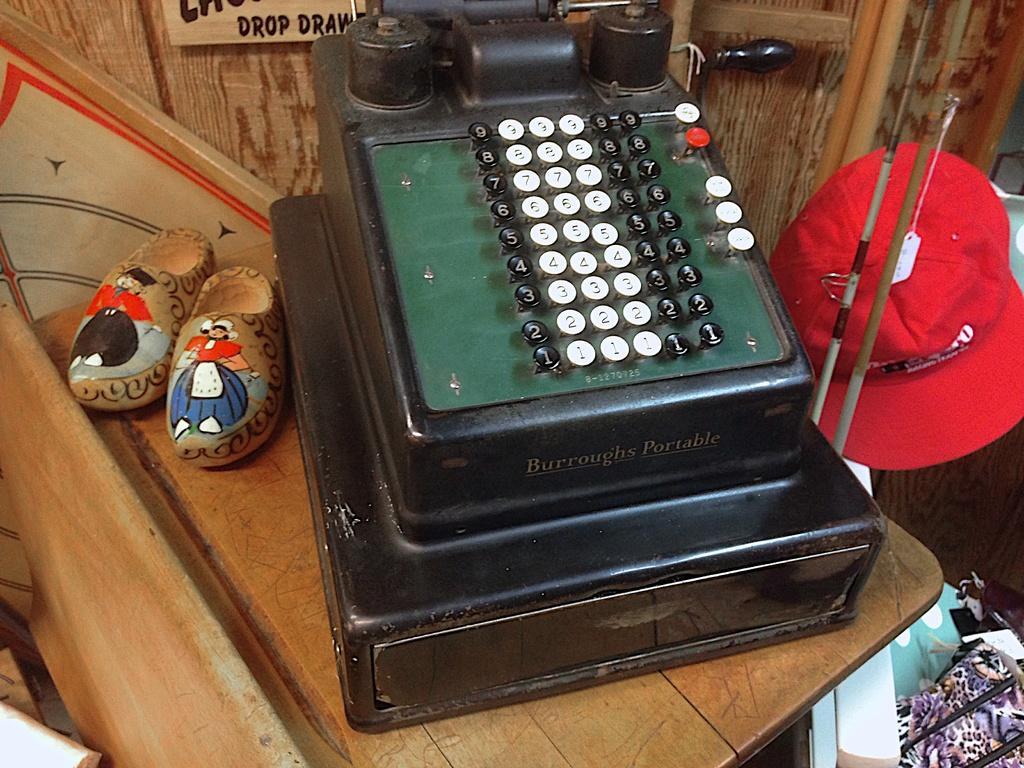Can you describe this image briefly? This is an adding machine and a pair of shoes are placed on the wooden table. This is a cap, which is red in color. At the top of the image, that looks like a name board, which is attached to the wall. I think these are the clothes. 